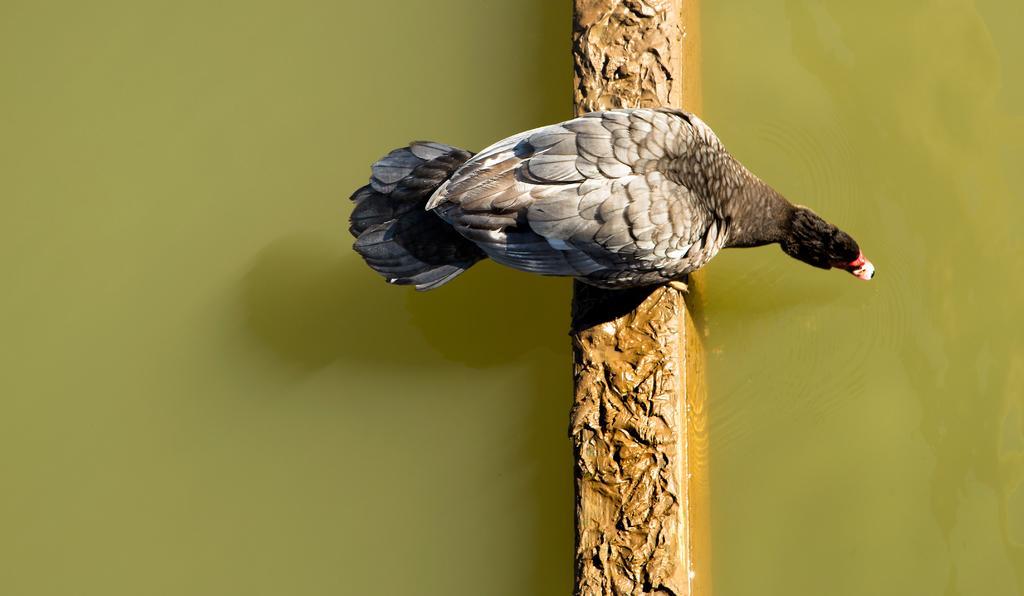In one or two sentences, can you explain what this image depicts? In this image, we can see a bird on the wall. Here we can see water. 